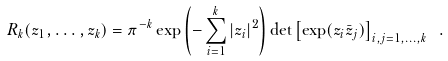<formula> <loc_0><loc_0><loc_500><loc_500>R _ { k } ( z _ { 1 } , \dots , z _ { k } ) = \pi ^ { - k } \exp \left ( - \sum _ { i = 1 } ^ { k } | z _ { i } | ^ { 2 } \right ) \det \left [ \exp ( z _ { i } { \bar { z } } _ { j } ) \right ] _ { i , j = 1 , \dots , k } \ .</formula> 